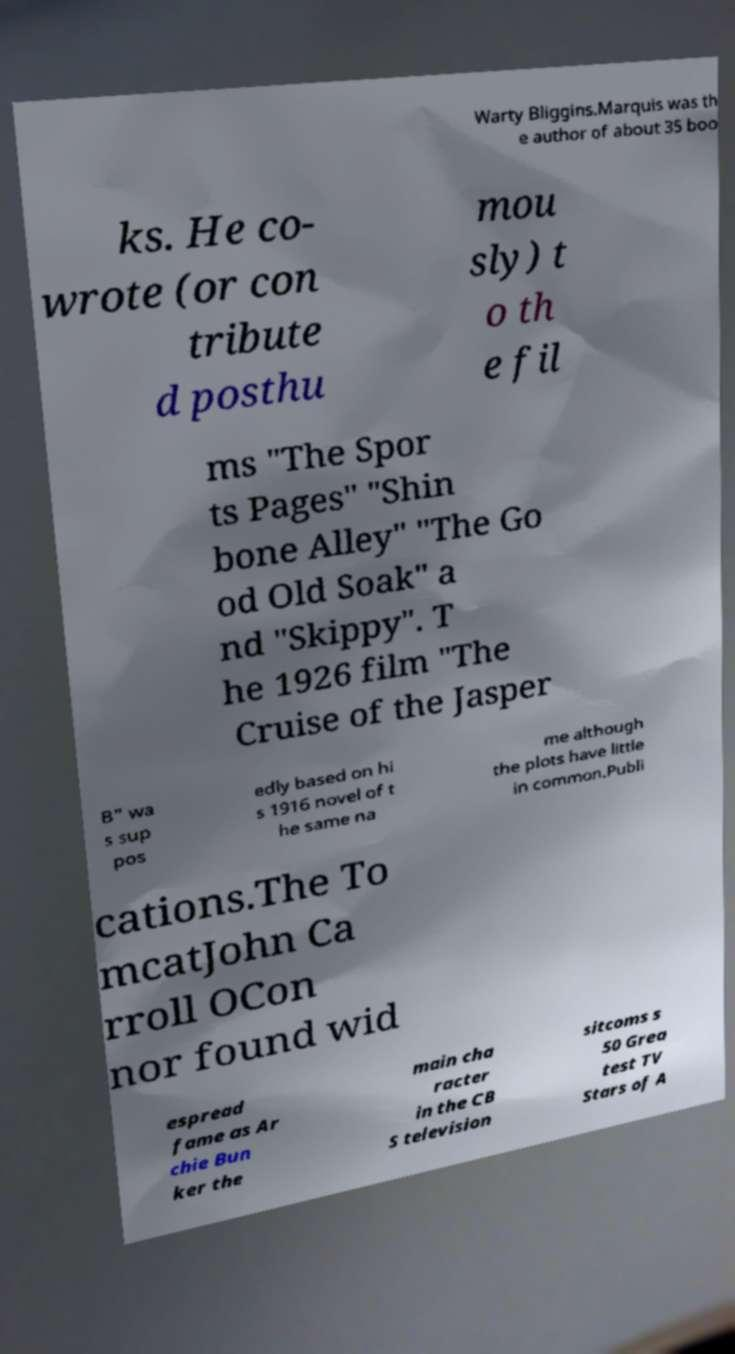For documentation purposes, I need the text within this image transcribed. Could you provide that? Warty Bliggins.Marquis was th e author of about 35 boo ks. He co- wrote (or con tribute d posthu mou sly) t o th e fil ms "The Spor ts Pages" "Shin bone Alley" "The Go od Old Soak" a nd "Skippy". T he 1926 film "The Cruise of the Jasper B" wa s sup pos edly based on hi s 1916 novel of t he same na me although the plots have little in common.Publi cations.The To mcatJohn Ca rroll OCon nor found wid espread fame as Ar chie Bun ker the main cha racter in the CB S television sitcoms s 50 Grea test TV Stars of A 